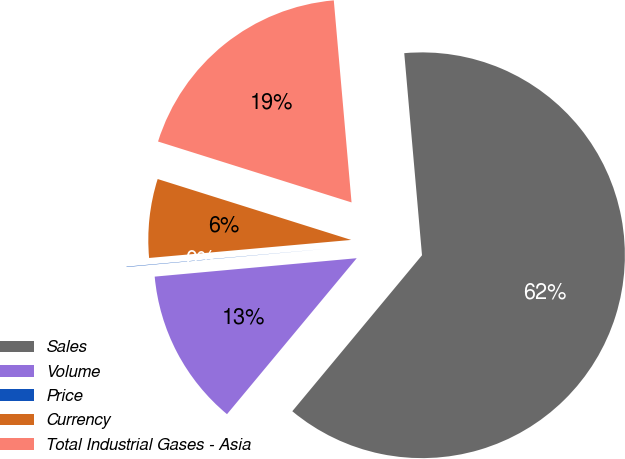Convert chart to OTSL. <chart><loc_0><loc_0><loc_500><loc_500><pie_chart><fcel>Sales<fcel>Volume<fcel>Price<fcel>Currency<fcel>Total Industrial Gases - Asia<nl><fcel>62.43%<fcel>12.51%<fcel>0.03%<fcel>6.27%<fcel>18.75%<nl></chart> 